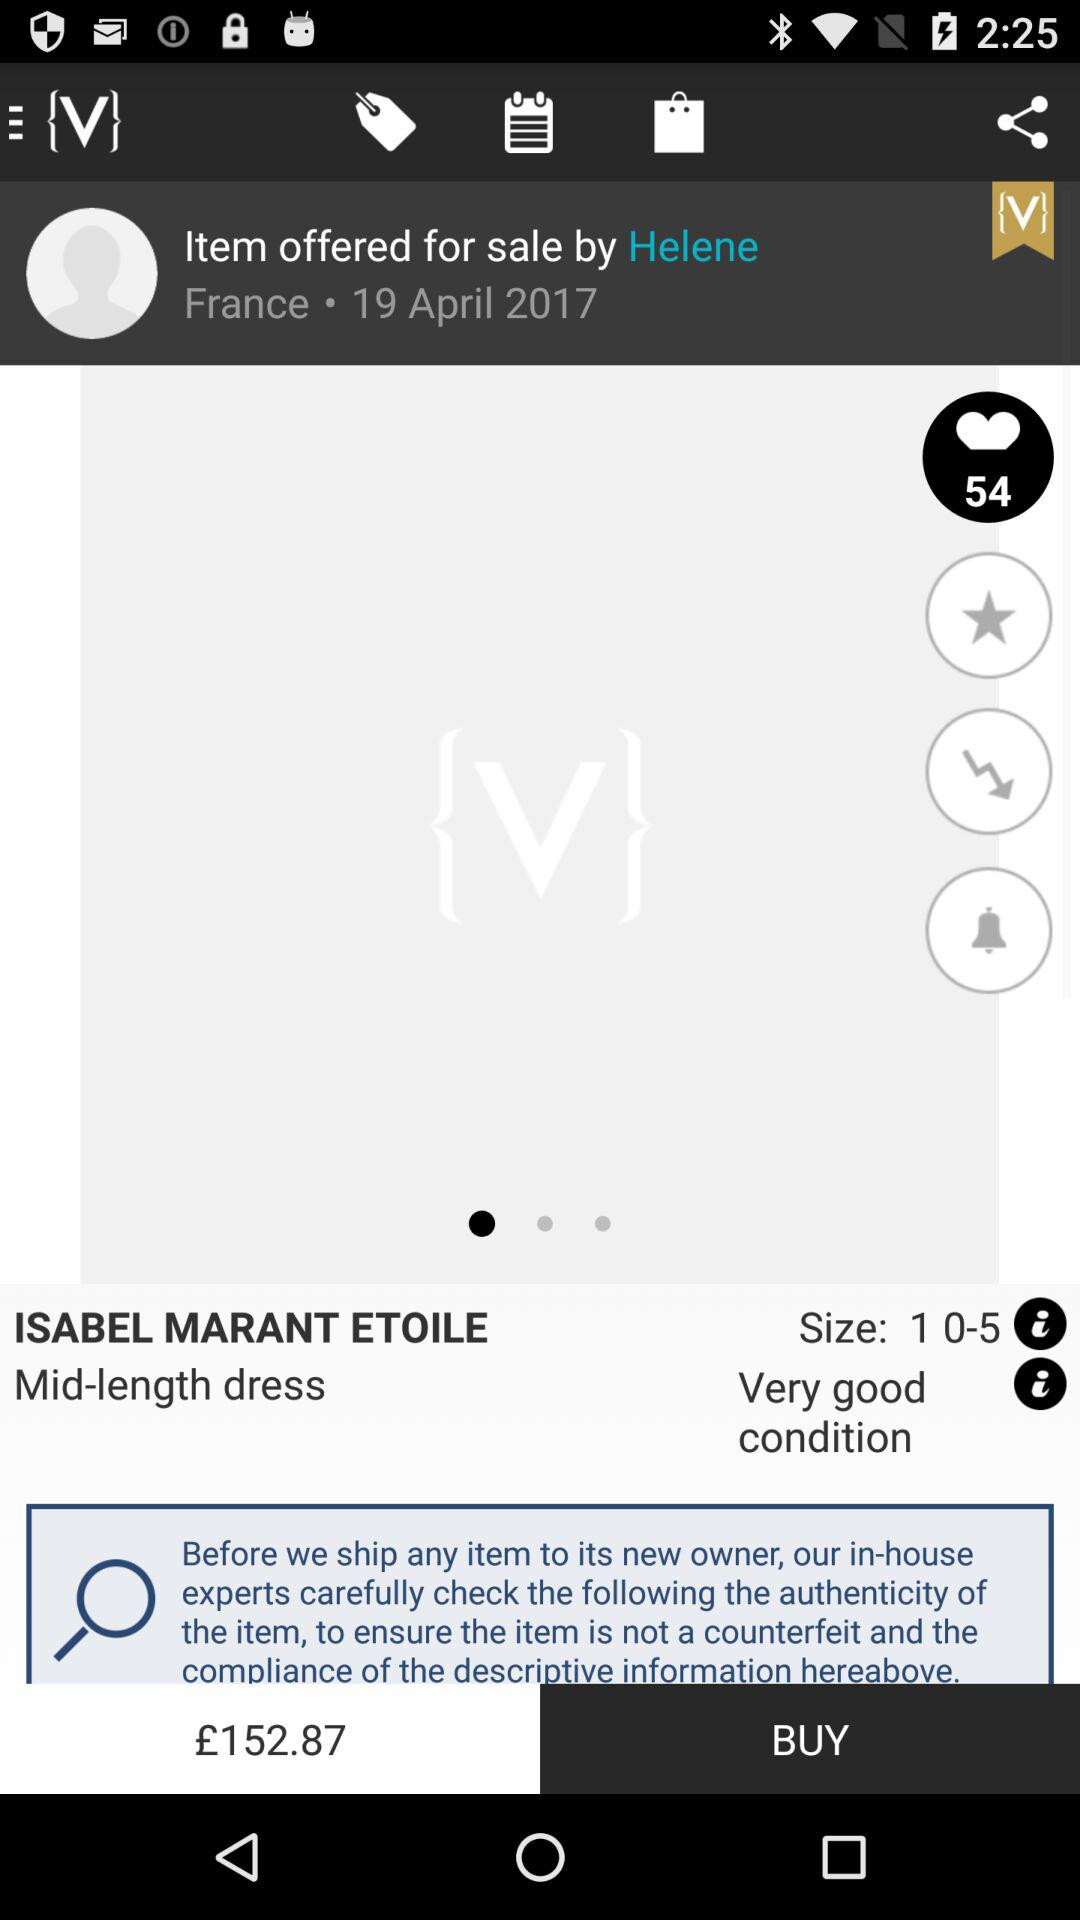How much is the item with shipping?
Answer the question using a single word or phrase. £152.87 